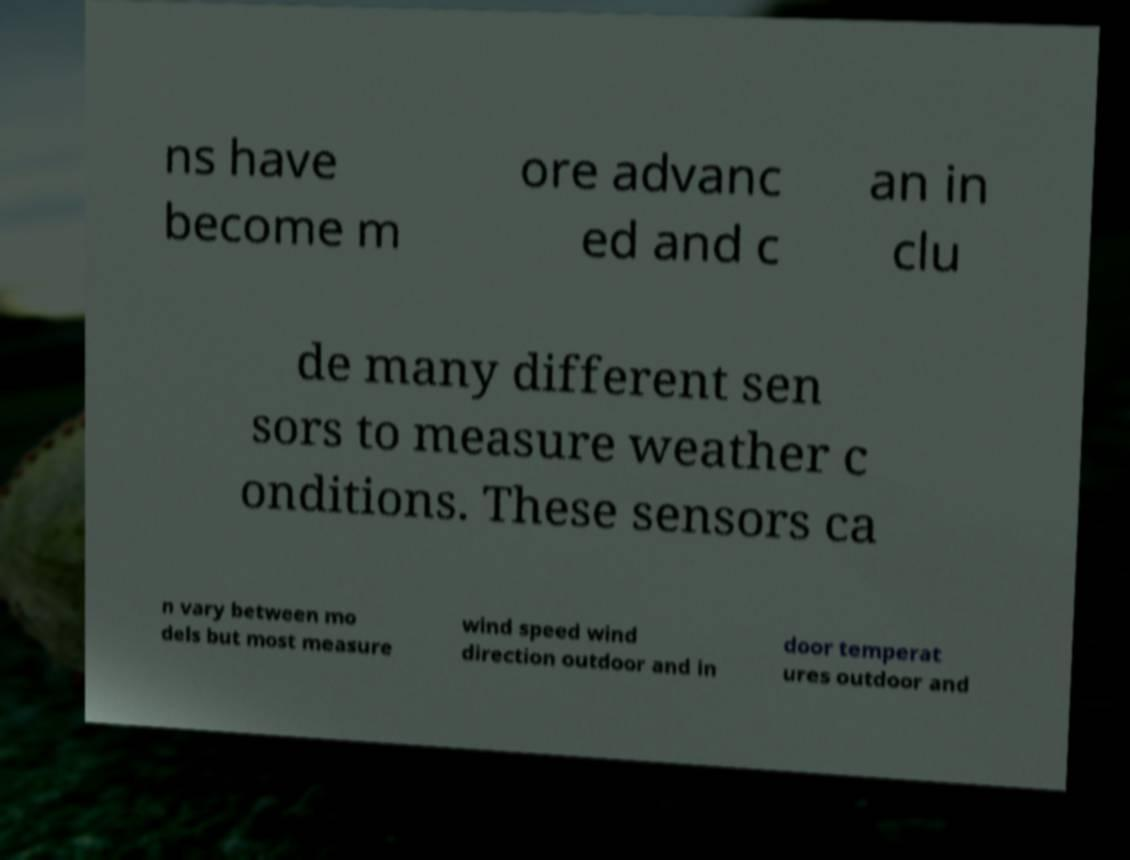There's text embedded in this image that I need extracted. Can you transcribe it verbatim? ns have become m ore advanc ed and c an in clu de many different sen sors to measure weather c onditions. These sensors ca n vary between mo dels but most measure wind speed wind direction outdoor and in door temperat ures outdoor and 